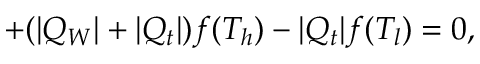<formula> <loc_0><loc_0><loc_500><loc_500>+ ( | Q _ { W } | + | Q _ { t } | ) f ( T _ { h } ) - | Q _ { t } | f ( T _ { l } ) = 0 ,</formula> 